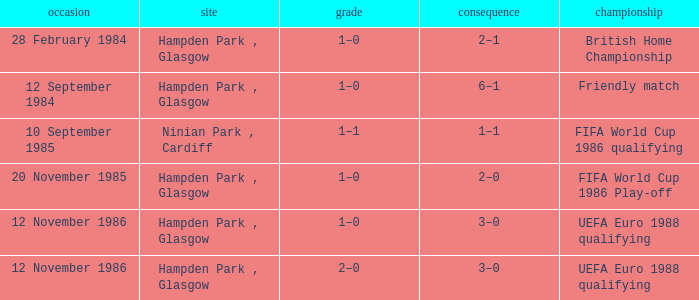What is the Date of the Competition with a Result of 3–0? 12 November 1986, 12 November 1986. 